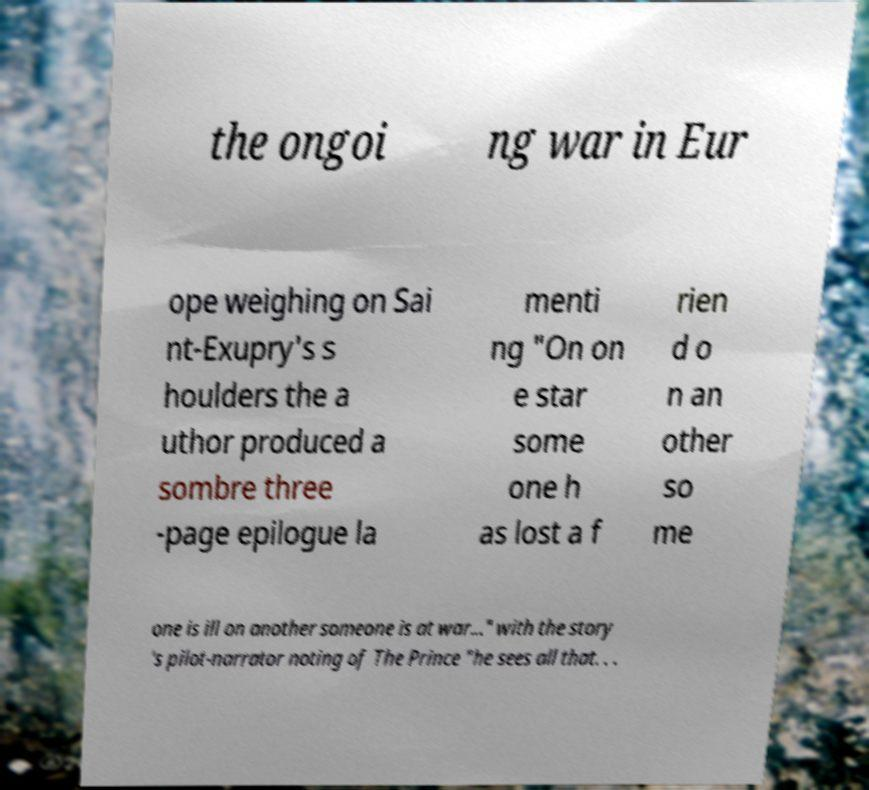Could you extract and type out the text from this image? the ongoi ng war in Eur ope weighing on Sai nt-Exupry's s houlders the a uthor produced a sombre three -page epilogue la menti ng "On on e star some one h as lost a f rien d o n an other so me one is ill on another someone is at war..." with the story 's pilot-narrator noting of The Prince "he sees all that. . . 